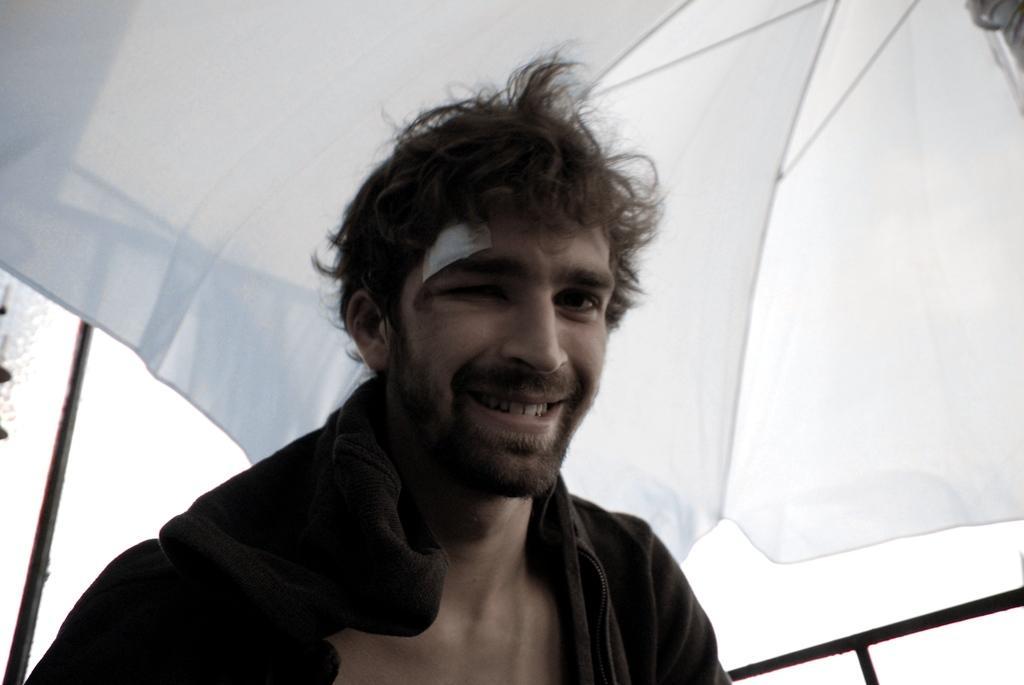Can you describe this image briefly? In this image we can see a man and he is smiling. In the background we can see an umbrella. 